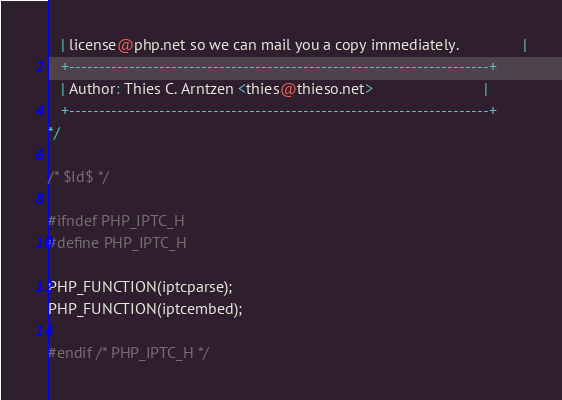<code> <loc_0><loc_0><loc_500><loc_500><_C_>   | license@php.net so we can mail you a copy immediately.               |
   +----------------------------------------------------------------------+
   | Author: Thies C. Arntzen <thies@thieso.net>                          |
   +----------------------------------------------------------------------+
*/

/* $Id$ */

#ifndef PHP_IPTC_H
#define PHP_IPTC_H

PHP_FUNCTION(iptcparse);
PHP_FUNCTION(iptcembed);

#endif /* PHP_IPTC_H */
</code> 